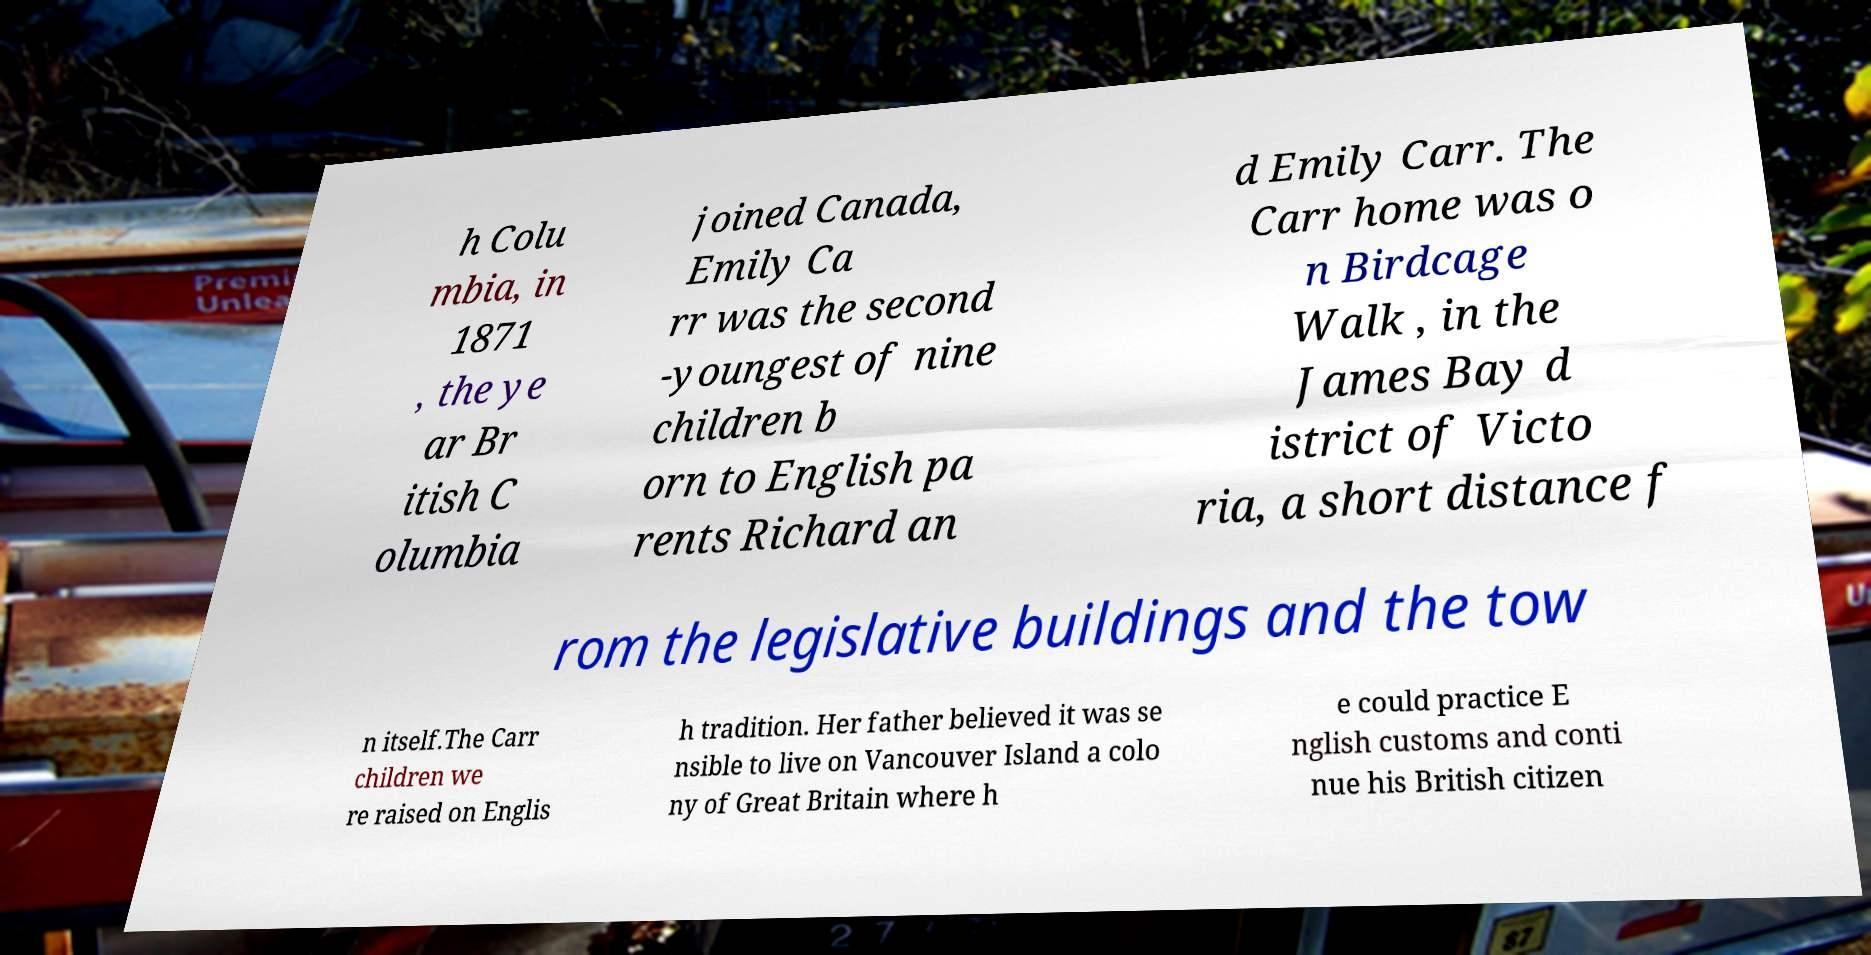Could you assist in decoding the text presented in this image and type it out clearly? h Colu mbia, in 1871 , the ye ar Br itish C olumbia joined Canada, Emily Ca rr was the second -youngest of nine children b orn to English pa rents Richard an d Emily Carr. The Carr home was o n Birdcage Walk , in the James Bay d istrict of Victo ria, a short distance f rom the legislative buildings and the tow n itself.The Carr children we re raised on Englis h tradition. Her father believed it was se nsible to live on Vancouver Island a colo ny of Great Britain where h e could practice E nglish customs and conti nue his British citizen 